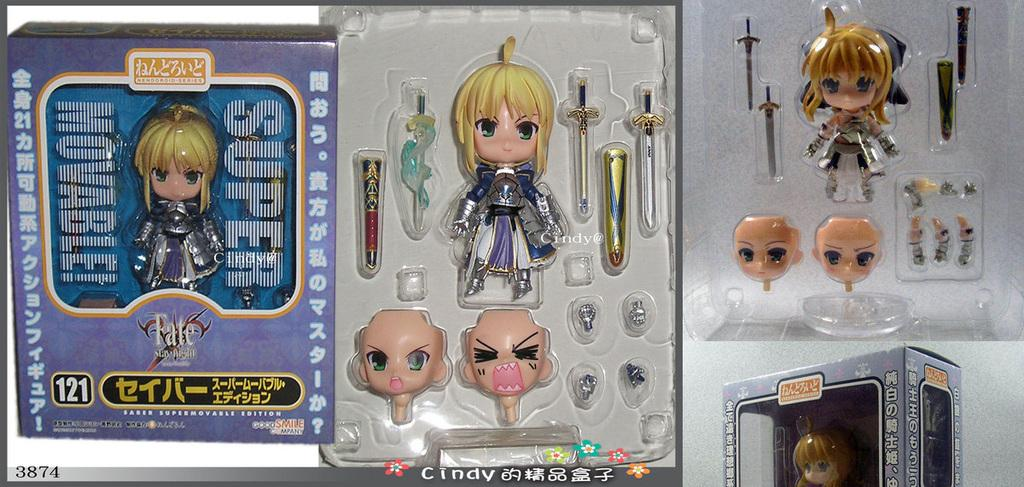What objects are present in the image? There are toys in the image. How are the toys arranged or stored in the image? The toys are in boxes. What type of hydrant can be seen in the image? There is no hydrant present in the image. How many feet are visible in the image? There are no feet visible in the image. 